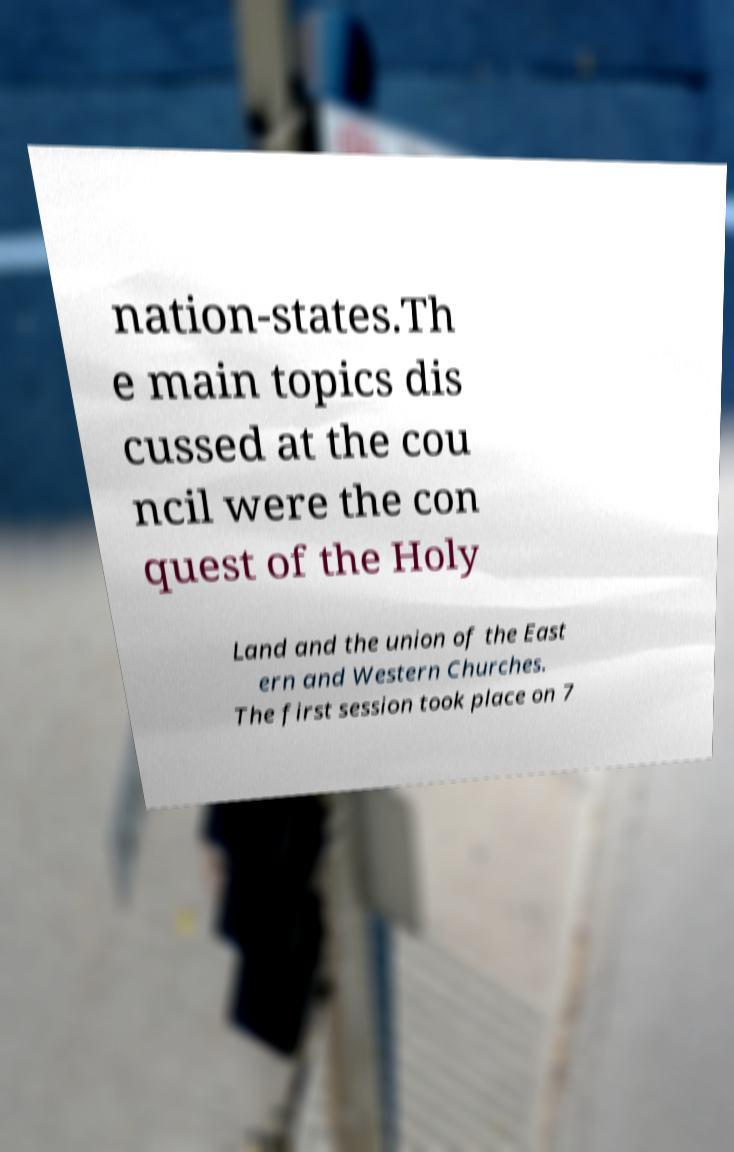What messages or text are displayed in this image? I need them in a readable, typed format. nation-states.Th e main topics dis cussed at the cou ncil were the con quest of the Holy Land and the union of the East ern and Western Churches. The first session took place on 7 